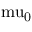<formula> <loc_0><loc_0><loc_500><loc_500>\ m u _ { 0 }</formula> 